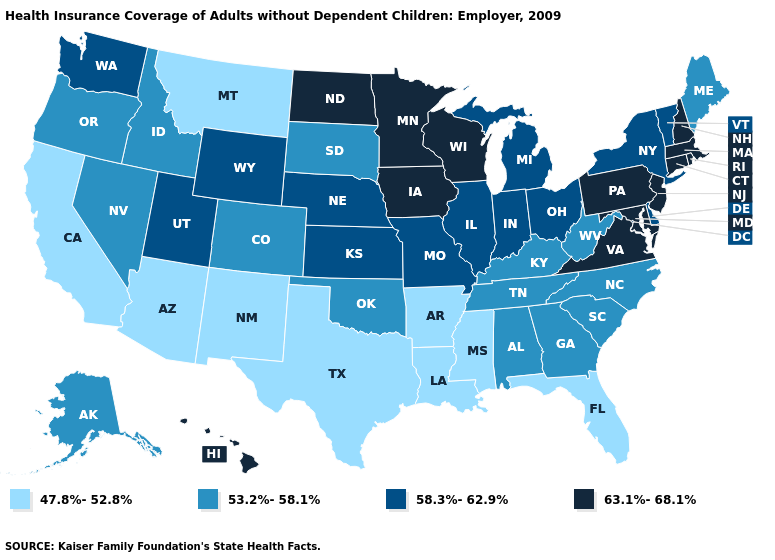Which states have the highest value in the USA?
Be succinct. Connecticut, Hawaii, Iowa, Maryland, Massachusetts, Minnesota, New Hampshire, New Jersey, North Dakota, Pennsylvania, Rhode Island, Virginia, Wisconsin. Does Mississippi have the lowest value in the USA?
Write a very short answer. Yes. Among the states that border South Dakota , does Montana have the lowest value?
Keep it brief. Yes. Does the map have missing data?
Write a very short answer. No. What is the value of New York?
Write a very short answer. 58.3%-62.9%. Does Maine have the lowest value in the Northeast?
Be succinct. Yes. Name the states that have a value in the range 63.1%-68.1%?
Give a very brief answer. Connecticut, Hawaii, Iowa, Maryland, Massachusetts, Minnesota, New Hampshire, New Jersey, North Dakota, Pennsylvania, Rhode Island, Virginia, Wisconsin. Which states hav the highest value in the MidWest?
Write a very short answer. Iowa, Minnesota, North Dakota, Wisconsin. Name the states that have a value in the range 63.1%-68.1%?
Short answer required. Connecticut, Hawaii, Iowa, Maryland, Massachusetts, Minnesota, New Hampshire, New Jersey, North Dakota, Pennsylvania, Rhode Island, Virginia, Wisconsin. Among the states that border Colorado , which have the highest value?
Keep it brief. Kansas, Nebraska, Utah, Wyoming. Which states hav the highest value in the South?
Short answer required. Maryland, Virginia. What is the highest value in states that border Rhode Island?
Quick response, please. 63.1%-68.1%. What is the value of California?
Write a very short answer. 47.8%-52.8%. What is the value of New York?
Answer briefly. 58.3%-62.9%. Does California have a lower value than Tennessee?
Short answer required. Yes. 